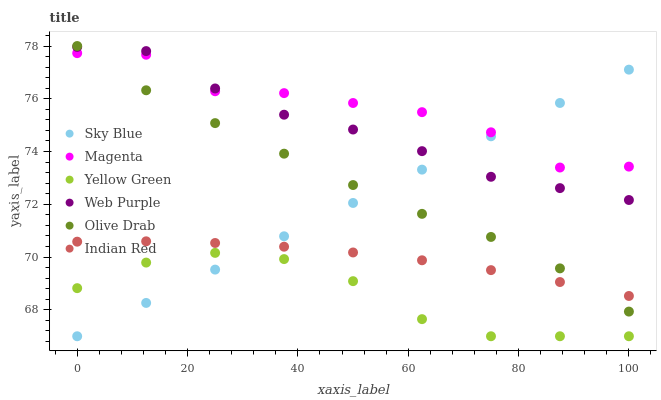Does Yellow Green have the minimum area under the curve?
Answer yes or no. Yes. Does Magenta have the maximum area under the curve?
Answer yes or no. Yes. Does Web Purple have the minimum area under the curve?
Answer yes or no. No. Does Web Purple have the maximum area under the curve?
Answer yes or no. No. Is Sky Blue the smoothest?
Answer yes or no. Yes. Is Magenta the roughest?
Answer yes or no. Yes. Is Web Purple the smoothest?
Answer yes or no. No. Is Web Purple the roughest?
Answer yes or no. No. Does Yellow Green have the lowest value?
Answer yes or no. Yes. Does Web Purple have the lowest value?
Answer yes or no. No. Does Olive Drab have the highest value?
Answer yes or no. Yes. Does Web Purple have the highest value?
Answer yes or no. No. Is Yellow Green less than Magenta?
Answer yes or no. Yes. Is Magenta greater than Indian Red?
Answer yes or no. Yes. Does Olive Drab intersect Web Purple?
Answer yes or no. Yes. Is Olive Drab less than Web Purple?
Answer yes or no. No. Is Olive Drab greater than Web Purple?
Answer yes or no. No. Does Yellow Green intersect Magenta?
Answer yes or no. No. 